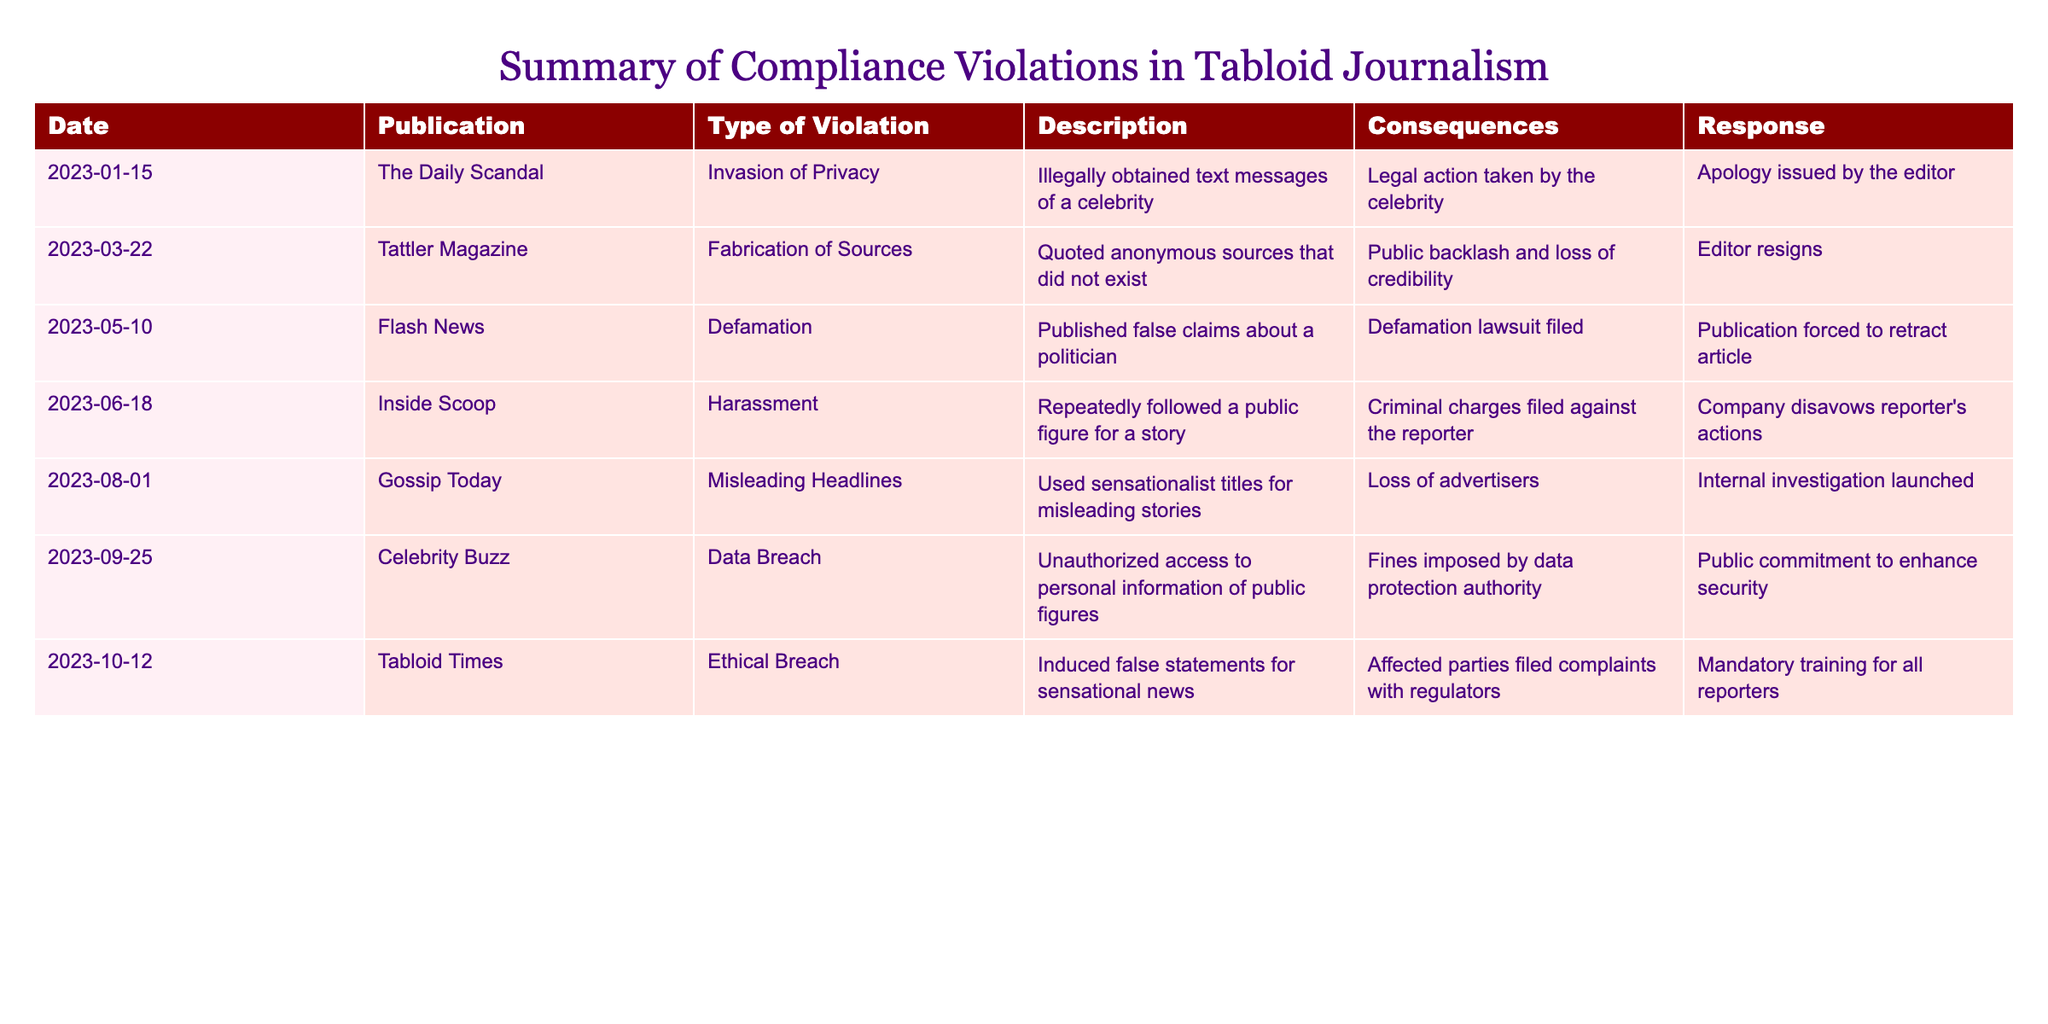What was the most recent violation listed in the table? The most recent date in the table is 2023-10-12, and the corresponding violation is recorded under Tabloid Times for an Ethical Breach.
Answer: Ethical Breach How many publications faced legal action due to compliance violations? The table lists three publications that resulted in legal actions: The Daily Scandal, Flash News, and Inside Scoop. Therefore, the count is three.
Answer: 3 What type of violation did Gossip Today commit? The table shows that Gossip Today committed a violation categorized as Misleading Headlines, which involved using sensationalist titles for misleading stories.
Answer: Misleading Headlines Did any publication face fines from a regulatory authority? The table indicates that Celebrity Buzz faced fines imposed by the data protection authority due to a Data Breach. Therefore, the answer is yes.
Answer: Yes Which violation had the consequence of an editor resigning? The table states that the violation committed by Tattler Magazine was the Fabrication of Sources, which led to the resignation of the editor.
Answer: Fabrication of Sources What is the total number of different types of violations listed in the table? The table displays six unique types of violations: Invasion of Privacy, Fabrication of Sources, Defamation, Harassment, Misleading Headlines, Data Breach, and Ethical Breach. Adding these gives a total of six.
Answer: 6 Was there any publication that induced false statements for sensational news? The violation described under Tabloid Times indicates that it did induce false statements for sensational news. Hence, the response is yes.
Answer: Yes What were the consequences for the violation related to data breach? The consequence described for the Data Breach by Celebrity Buzz is that fines were imposed by the data protection authority.
Answer: Fines imposed Which publication’s actions led to criminal charges being filed against a reporter? Inside Scoop is the publication from the table that faced criminal charges filed against a reporter due to harassment.
Answer: Inside Scoop 